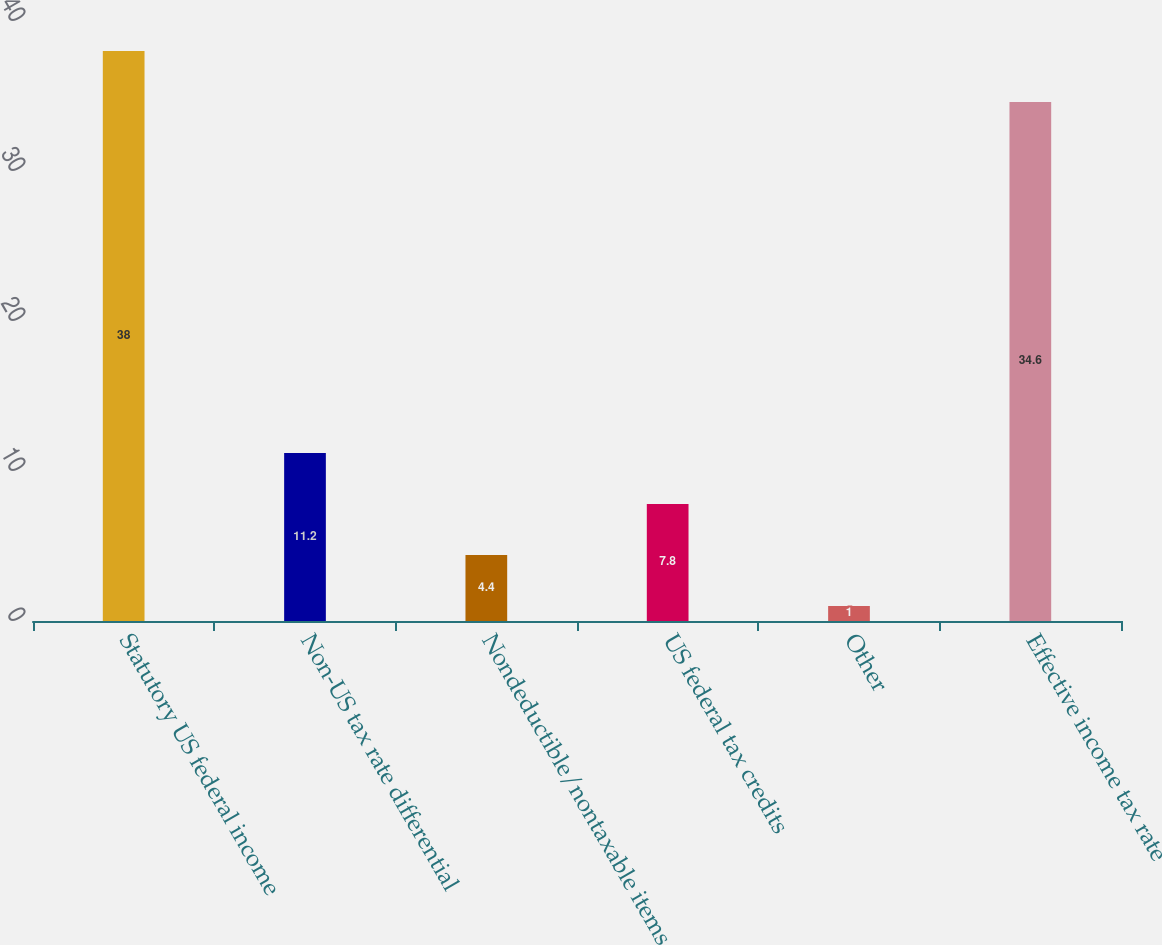Convert chart to OTSL. <chart><loc_0><loc_0><loc_500><loc_500><bar_chart><fcel>Statutory US federal income<fcel>Non-US tax rate differential<fcel>Nondeductible/nontaxable items<fcel>US federal tax credits<fcel>Other<fcel>Effective income tax rate<nl><fcel>38<fcel>11.2<fcel>4.4<fcel>7.8<fcel>1<fcel>34.6<nl></chart> 